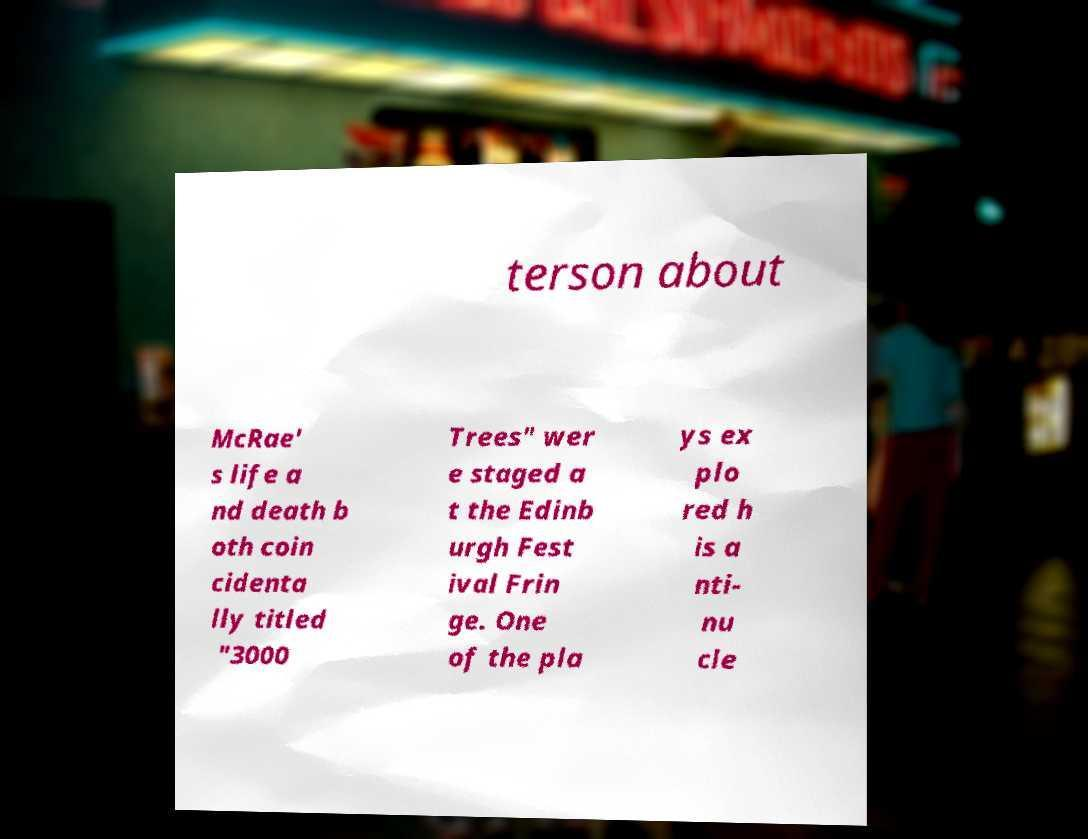There's text embedded in this image that I need extracted. Can you transcribe it verbatim? terson about McRae' s life a nd death b oth coin cidenta lly titled "3000 Trees" wer e staged a t the Edinb urgh Fest ival Frin ge. One of the pla ys ex plo red h is a nti- nu cle 